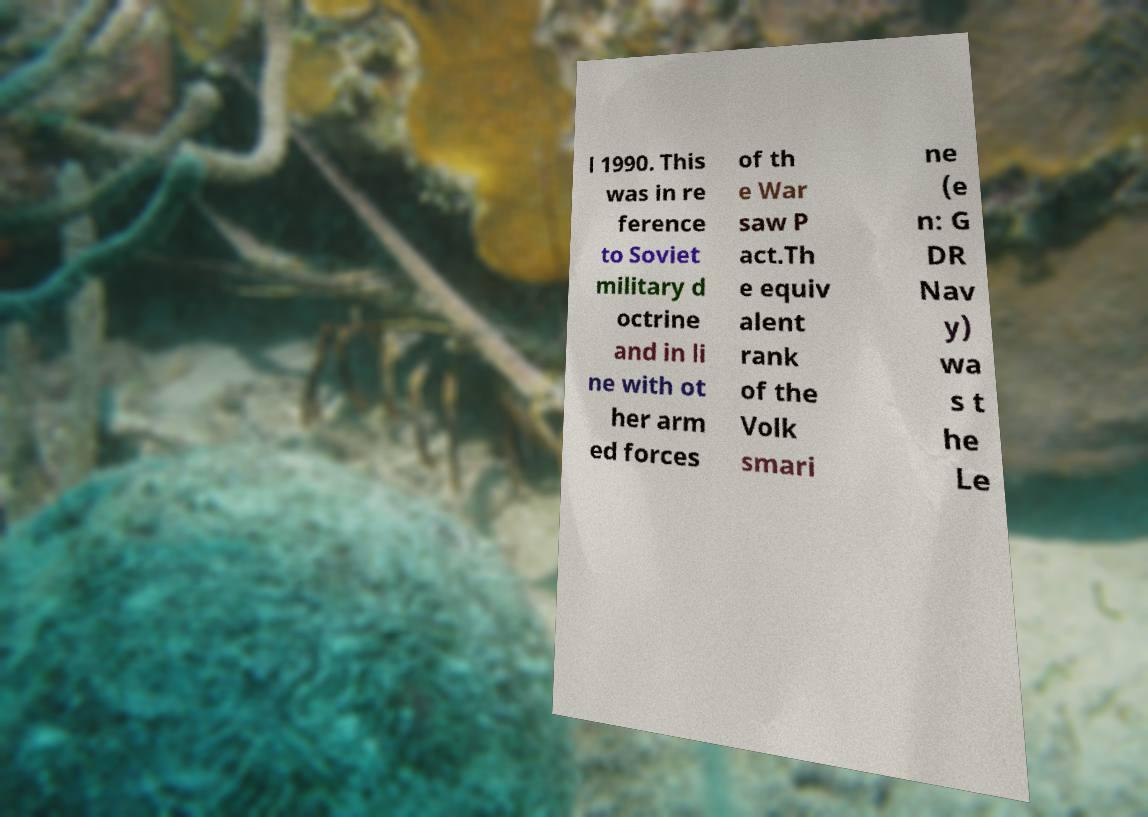Please identify and transcribe the text found in this image. l 1990. This was in re ference to Soviet military d octrine and in li ne with ot her arm ed forces of th e War saw P act.Th e equiv alent rank of the Volk smari ne (e n: G DR Nav y) wa s t he Le 